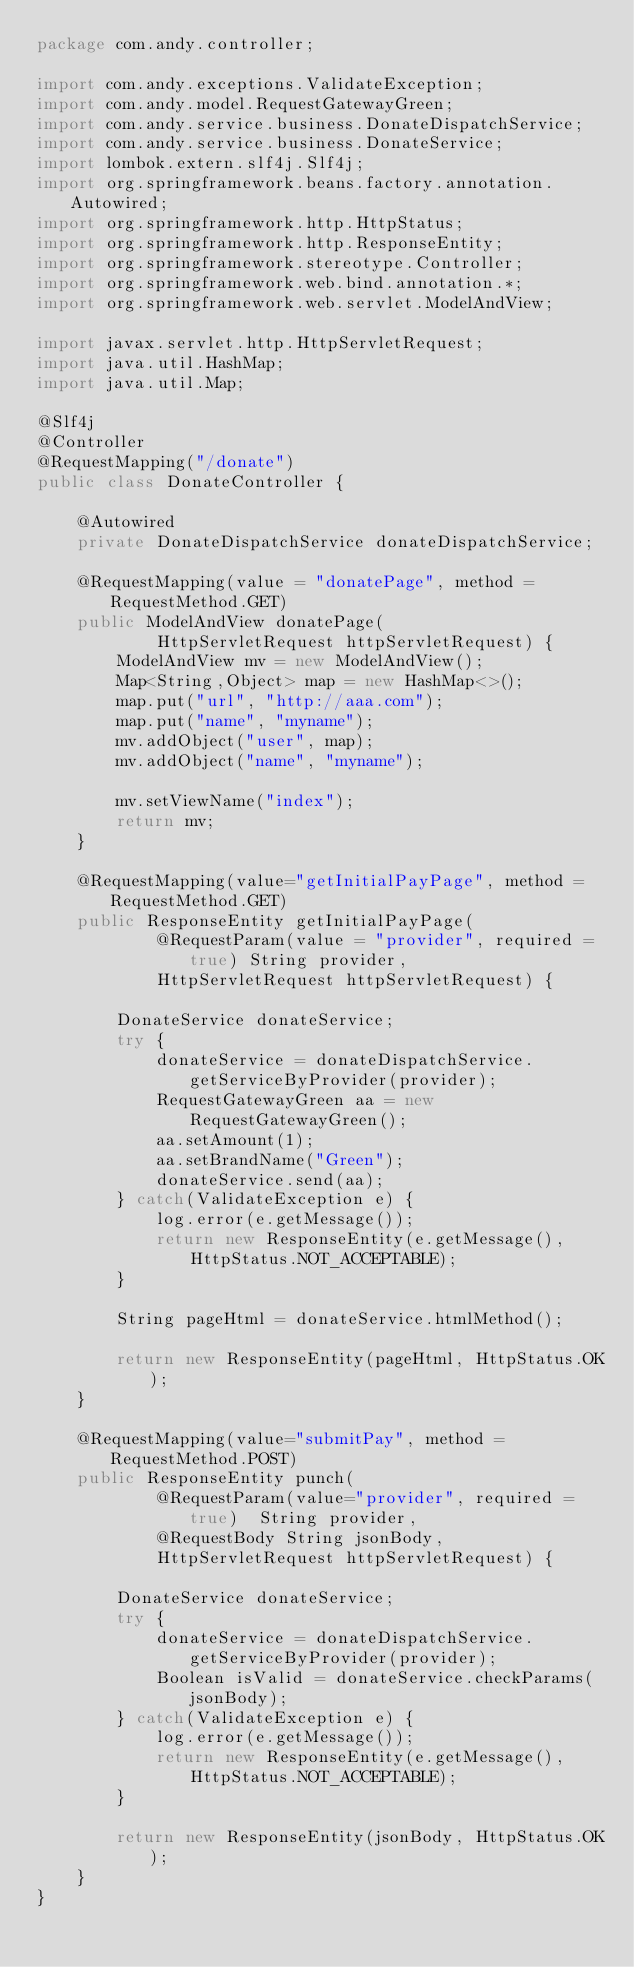<code> <loc_0><loc_0><loc_500><loc_500><_Java_>package com.andy.controller;

import com.andy.exceptions.ValidateException;
import com.andy.model.RequestGatewayGreen;
import com.andy.service.business.DonateDispatchService;
import com.andy.service.business.DonateService;
import lombok.extern.slf4j.Slf4j;
import org.springframework.beans.factory.annotation.Autowired;
import org.springframework.http.HttpStatus;
import org.springframework.http.ResponseEntity;
import org.springframework.stereotype.Controller;
import org.springframework.web.bind.annotation.*;
import org.springframework.web.servlet.ModelAndView;

import javax.servlet.http.HttpServletRequest;
import java.util.HashMap;
import java.util.Map;

@Slf4j
@Controller
@RequestMapping("/donate")
public class DonateController {

    @Autowired
    private DonateDispatchService donateDispatchService;

    @RequestMapping(value = "donatePage", method = RequestMethod.GET)
    public ModelAndView donatePage(
            HttpServletRequest httpServletRequest) {
        ModelAndView mv = new ModelAndView();
        Map<String,Object> map = new HashMap<>();
        map.put("url", "http://aaa.com");
        map.put("name", "myname");
        mv.addObject("user", map);
        mv.addObject("name", "myname");

        mv.setViewName("index");
        return mv;
    }

    @RequestMapping(value="getInitialPayPage", method = RequestMethod.GET)
    public ResponseEntity getInitialPayPage(
            @RequestParam(value = "provider", required = true) String provider,
            HttpServletRequest httpServletRequest) {

        DonateService donateService;
        try {
            donateService = donateDispatchService.getServiceByProvider(provider);
            RequestGatewayGreen aa = new RequestGatewayGreen();
            aa.setAmount(1);
            aa.setBrandName("Green");
            donateService.send(aa);
        } catch(ValidateException e) {
            log.error(e.getMessage());
            return new ResponseEntity(e.getMessage(), HttpStatus.NOT_ACCEPTABLE);
        }

        String pageHtml = donateService.htmlMethod();

        return new ResponseEntity(pageHtml, HttpStatus.OK);
    }

    @RequestMapping(value="submitPay", method = RequestMethod.POST)
    public ResponseEntity punch(
            @RequestParam(value="provider", required = true)  String provider,
            @RequestBody String jsonBody,
            HttpServletRequest httpServletRequest) {

        DonateService donateService;
        try {
            donateService = donateDispatchService.getServiceByProvider(provider);
            Boolean isValid = donateService.checkParams(jsonBody);
        } catch(ValidateException e) {
            log.error(e.getMessage());
            return new ResponseEntity(e.getMessage(), HttpStatus.NOT_ACCEPTABLE);
        }

        return new ResponseEntity(jsonBody, HttpStatus.OK);
    }
}
</code> 